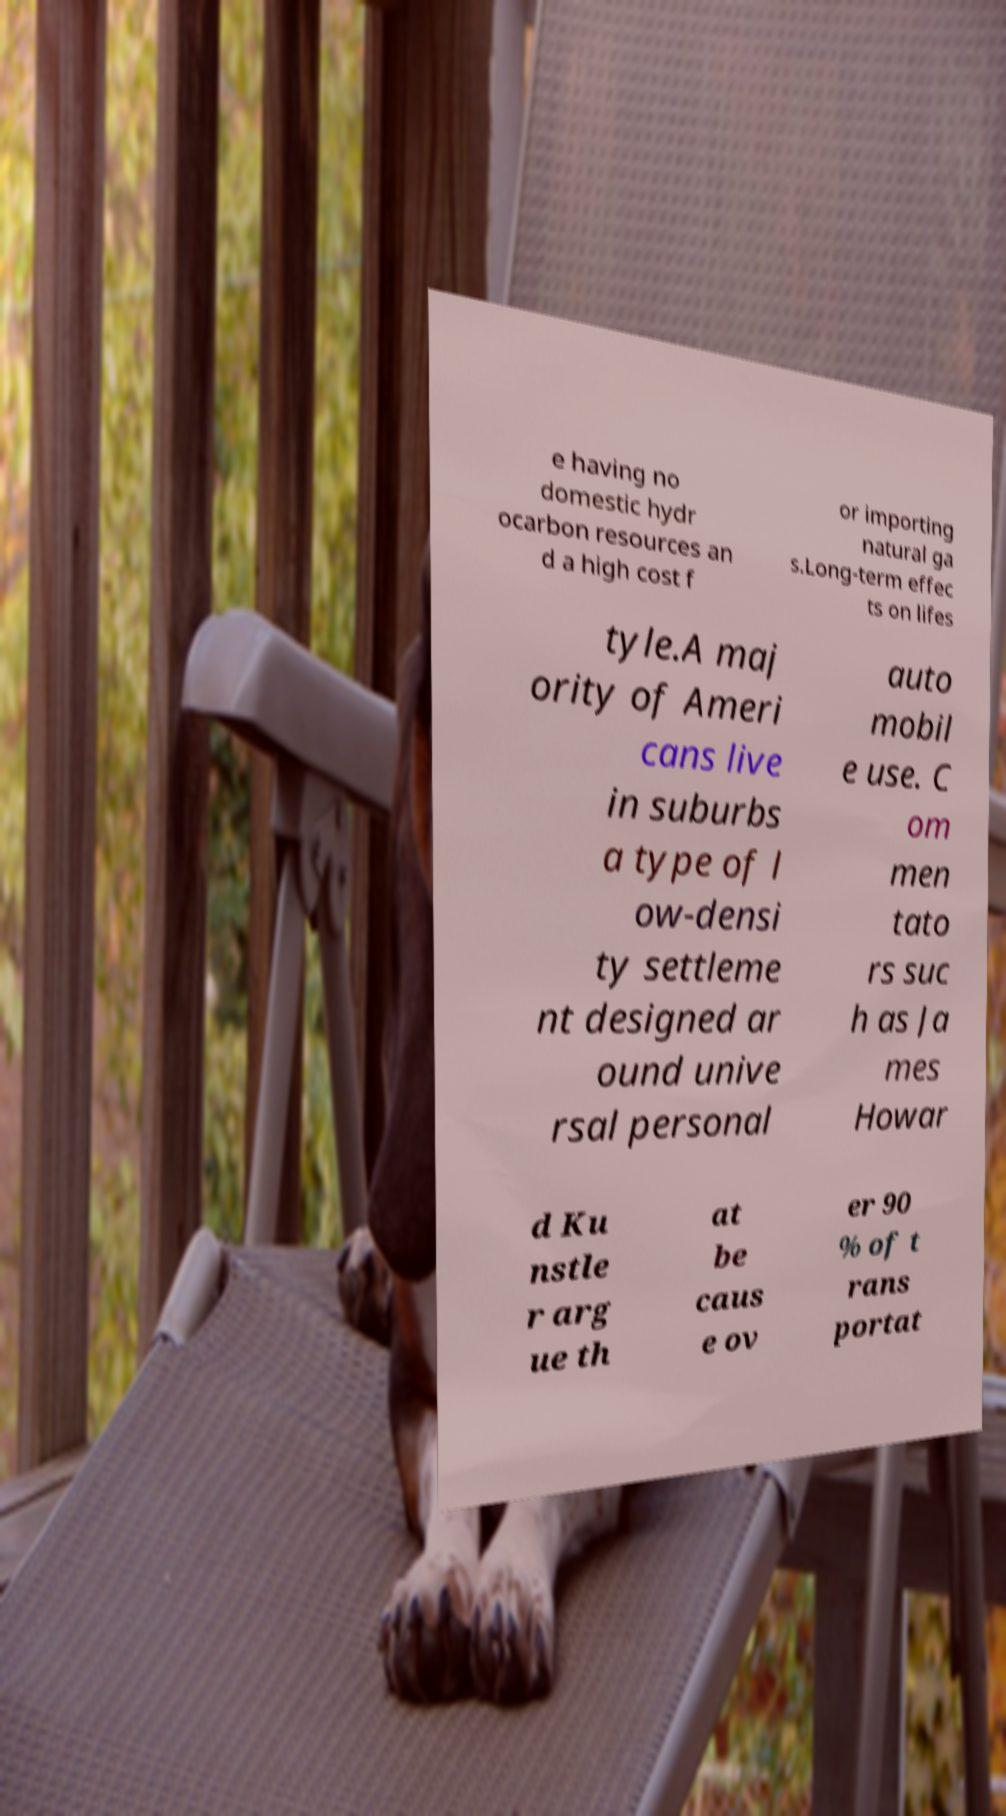Please identify and transcribe the text found in this image. e having no domestic hydr ocarbon resources an d a high cost f or importing natural ga s.Long-term effec ts on lifes tyle.A maj ority of Ameri cans live in suburbs a type of l ow-densi ty settleme nt designed ar ound unive rsal personal auto mobil e use. C om men tato rs suc h as Ja mes Howar d Ku nstle r arg ue th at be caus e ov er 90 % of t rans portat 